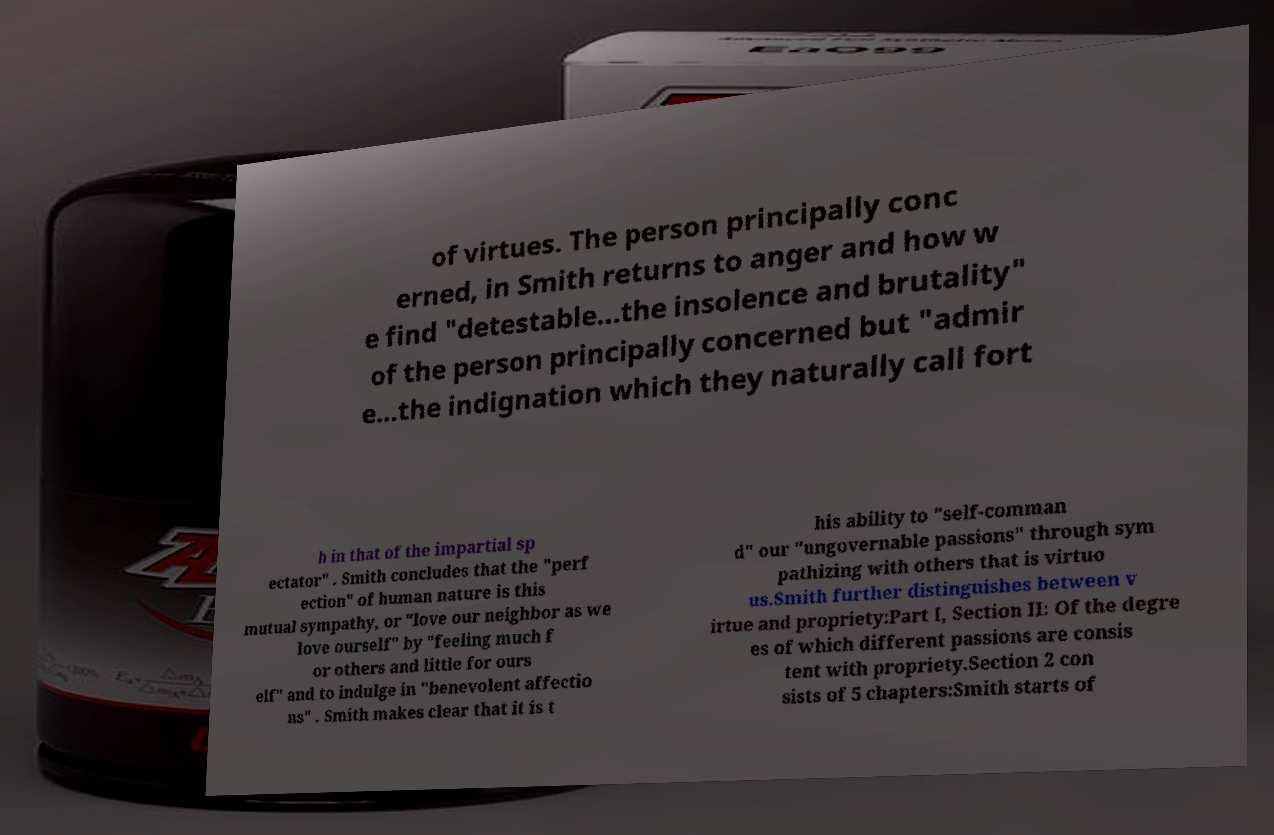For documentation purposes, I need the text within this image transcribed. Could you provide that? of virtues. The person principally conc erned, in Smith returns to anger and how w e find "detestable...the insolence and brutality" of the person principally concerned but "admir e...the indignation which they naturally call fort h in that of the impartial sp ectator" . Smith concludes that the "perf ection" of human nature is this mutual sympathy, or "love our neighbor as we love ourself" by "feeling much f or others and little for ours elf" and to indulge in "benevolent affectio ns" . Smith makes clear that it is t his ability to "self-comman d" our "ungovernable passions" through sym pathizing with others that is virtuo us.Smith further distinguishes between v irtue and propriety:Part I, Section II: Of the degre es of which different passions are consis tent with propriety.Section 2 con sists of 5 chapters:Smith starts of 